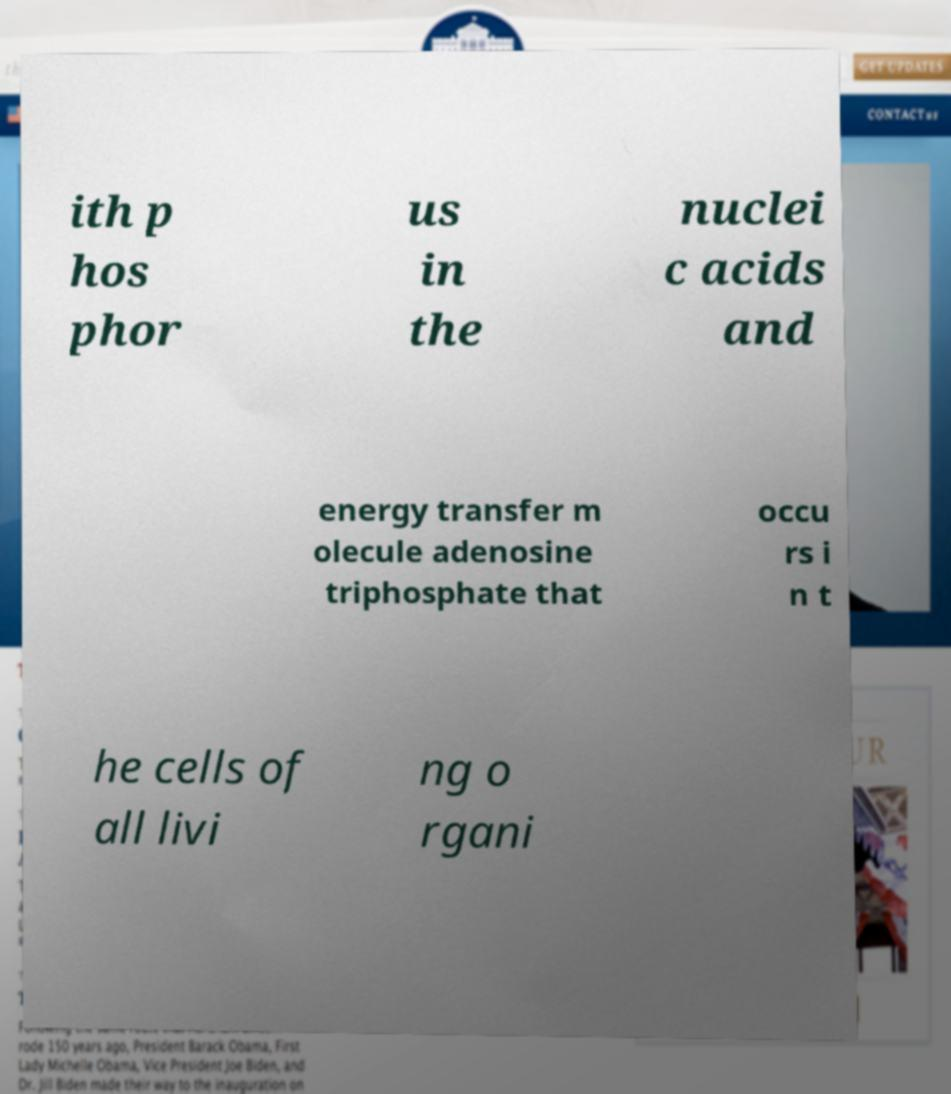Could you extract and type out the text from this image? ith p hos phor us in the nuclei c acids and energy transfer m olecule adenosine triphosphate that occu rs i n t he cells of all livi ng o rgani 